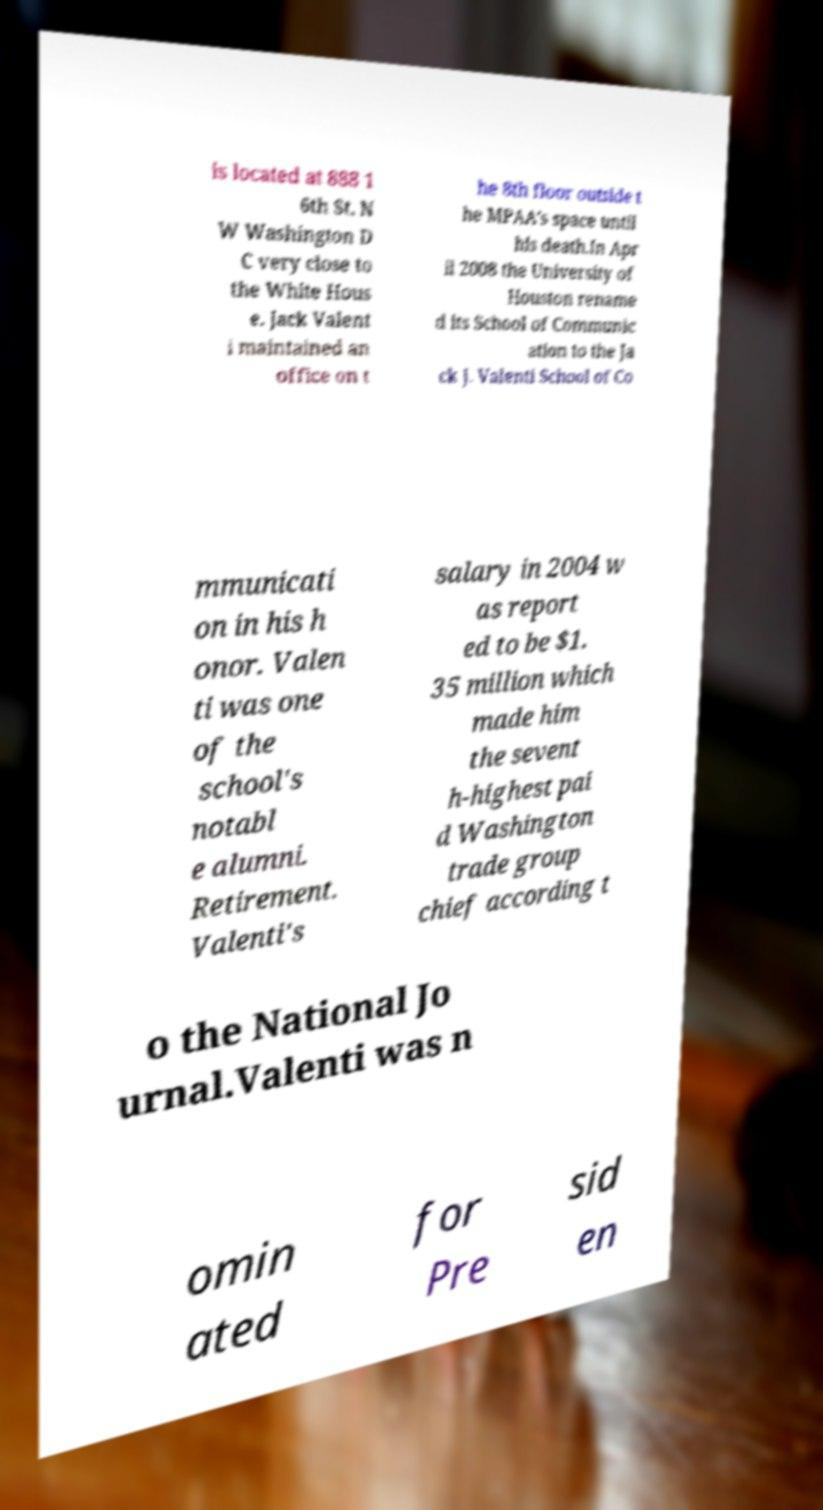Can you read and provide the text displayed in the image?This photo seems to have some interesting text. Can you extract and type it out for me? is located at 888 1 6th St. N W Washington D C very close to the White Hous e. Jack Valent i maintained an office on t he 8th floor outside t he MPAA's space until his death.In Apr il 2008 the University of Houston rename d its School of Communic ation to the Ja ck J. Valenti School of Co mmunicati on in his h onor. Valen ti was one of the school's notabl e alumni. Retirement. Valenti's salary in 2004 w as report ed to be $1. 35 million which made him the sevent h-highest pai d Washington trade group chief according t o the National Jo urnal.Valenti was n omin ated for Pre sid en 